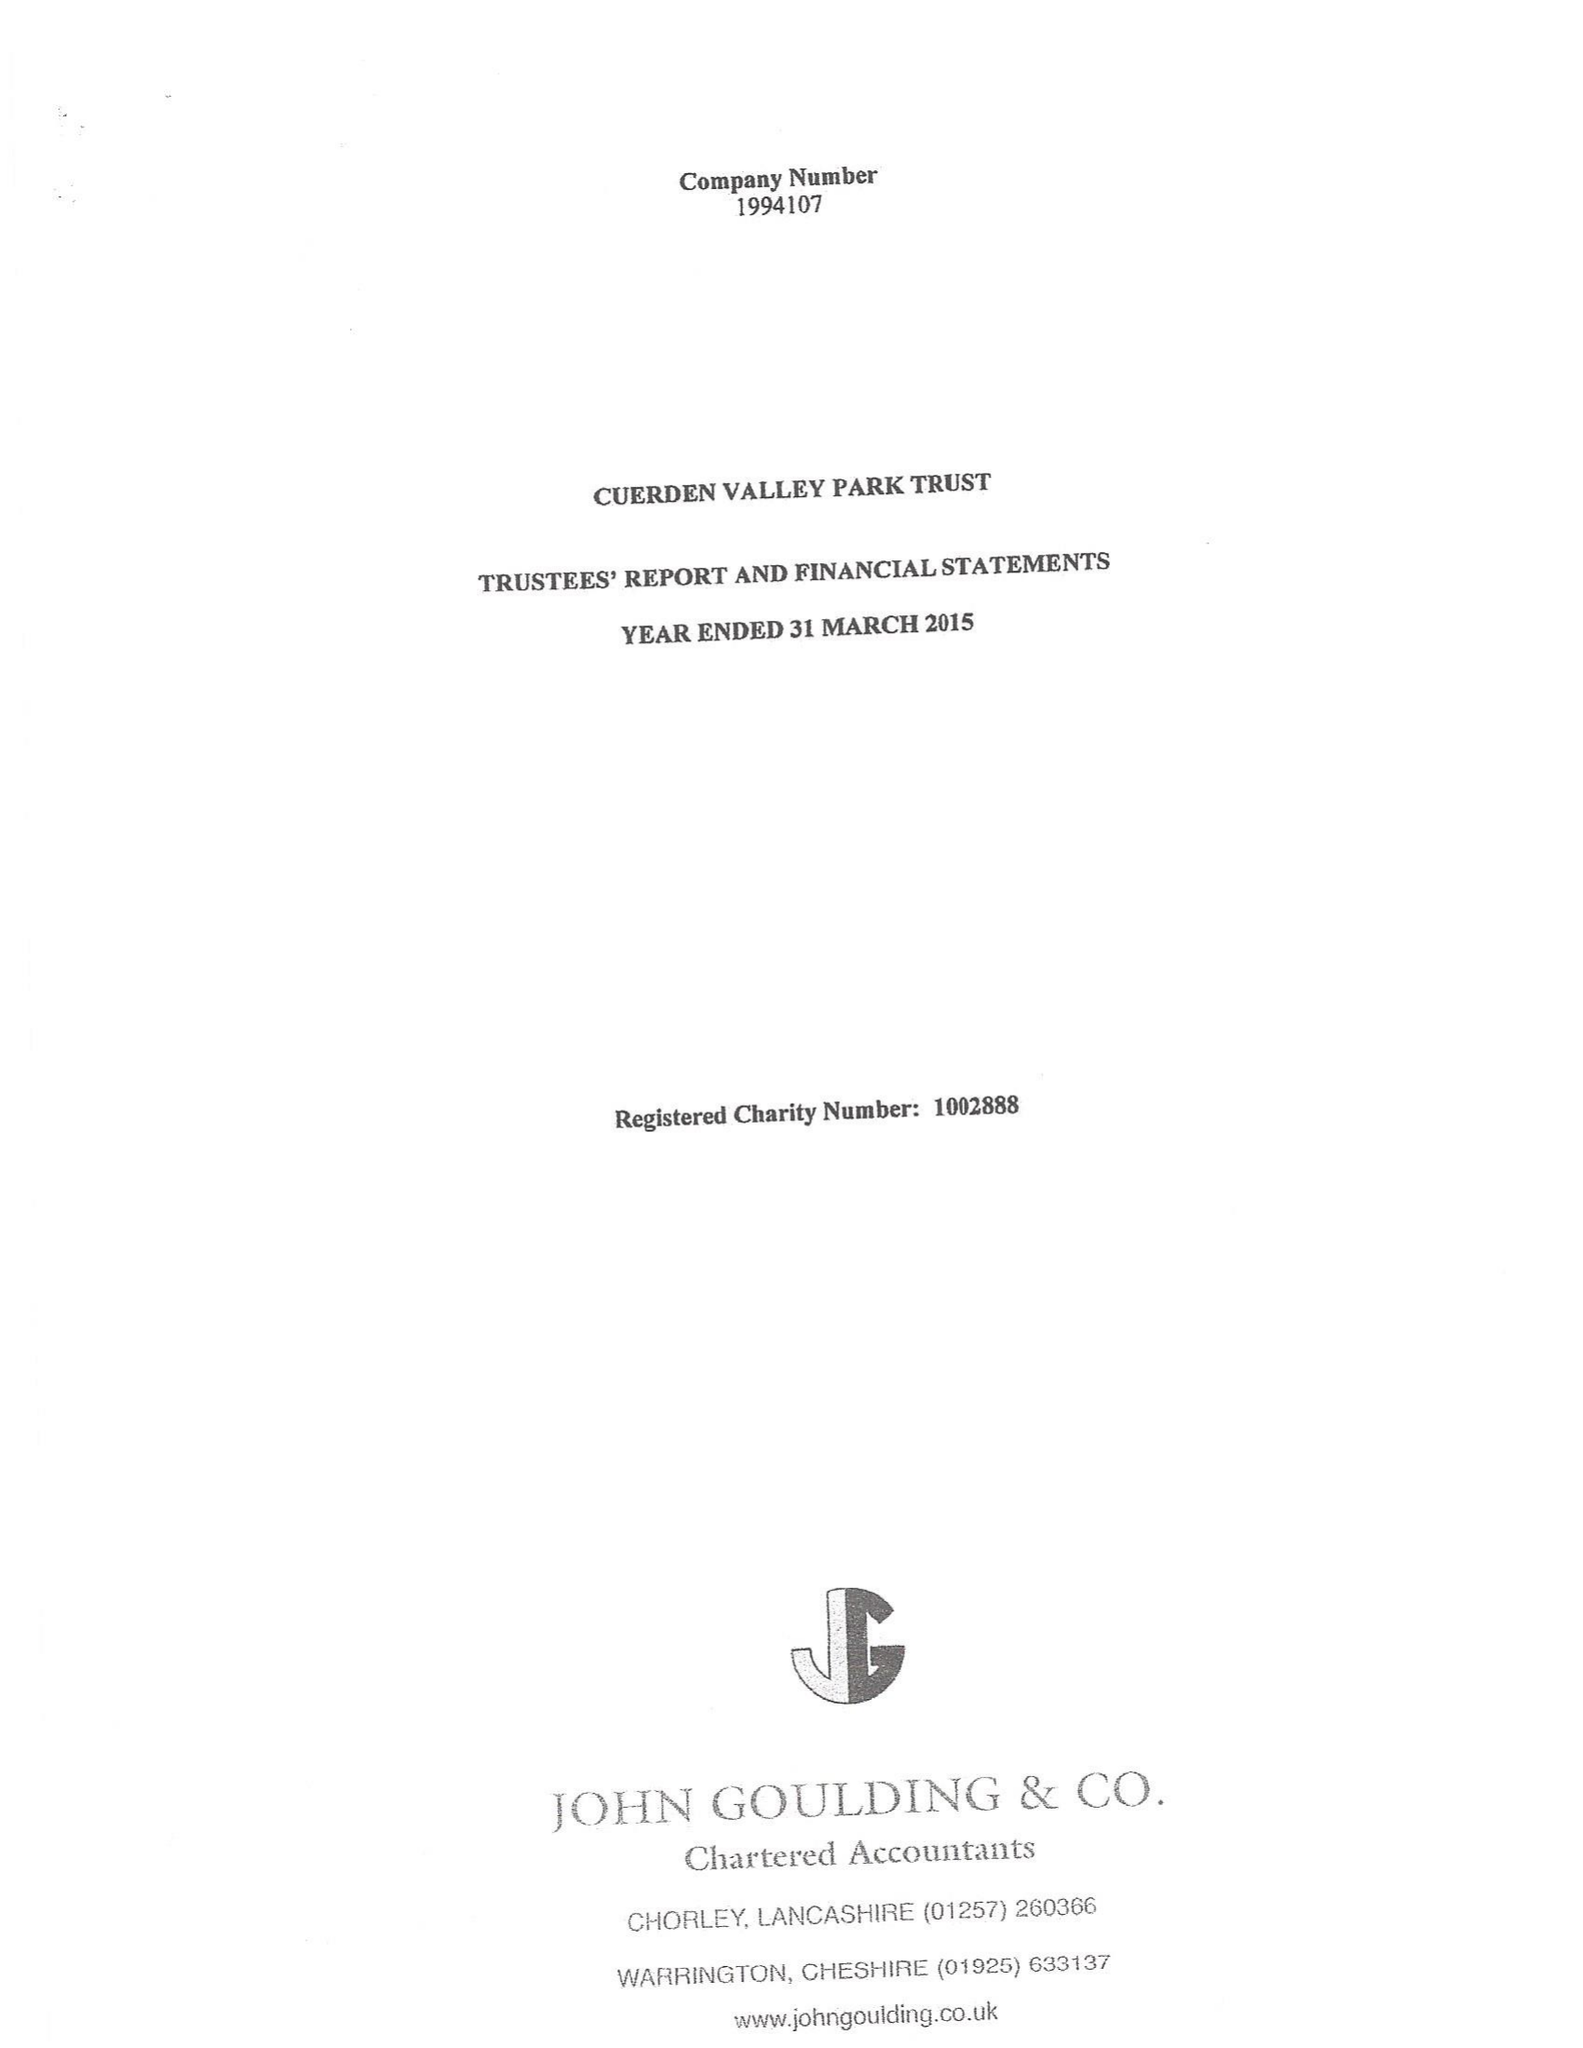What is the value for the charity_number?
Answer the question using a single word or phrase. 1002888 